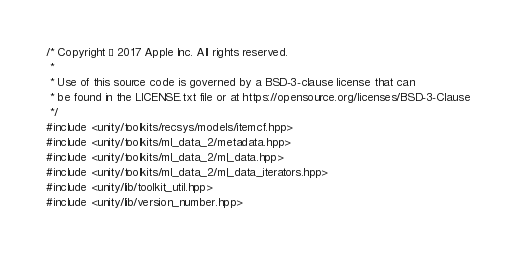Convert code to text. <code><loc_0><loc_0><loc_500><loc_500><_C++_>/* Copyright © 2017 Apple Inc. All rights reserved.
 *
 * Use of this source code is governed by a BSD-3-clause license that can
 * be found in the LICENSE.txt file or at https://opensource.org/licenses/BSD-3-Clause
 */
#include <unity/toolkits/recsys/models/itemcf.hpp>
#include <unity/toolkits/ml_data_2/metadata.hpp>
#include <unity/toolkits/ml_data_2/ml_data.hpp>
#include <unity/toolkits/ml_data_2/ml_data_iterators.hpp>
#include <unity/lib/toolkit_util.hpp>
#include <unity/lib/version_number.hpp></code> 